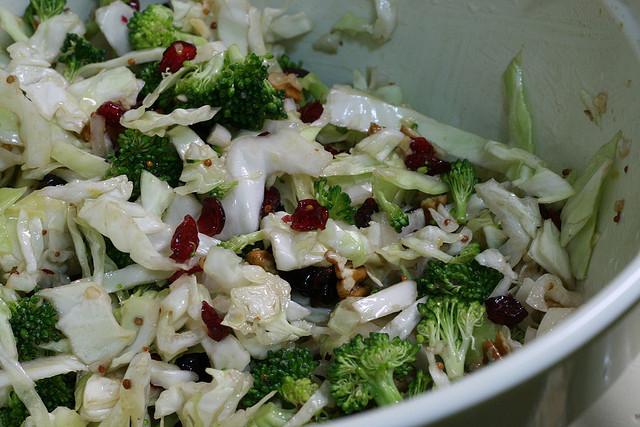Is this a main dish?
Give a very brief answer. No. Who left the mess on the plate?
Keep it brief. Someone. Is this a bowl full of happy veggies?
Write a very short answer. Yes. What is the green vegetable?
Be succinct. Broccoli. What are the green vegetables called?
Quick response, please. Broccoli. Is the fruit in this picture an ingredient in the pasta dish?
Answer briefly. No. What color is the bowl?
Quick response, please. White. Is the salad sweet?
Short answer required. Yes. 